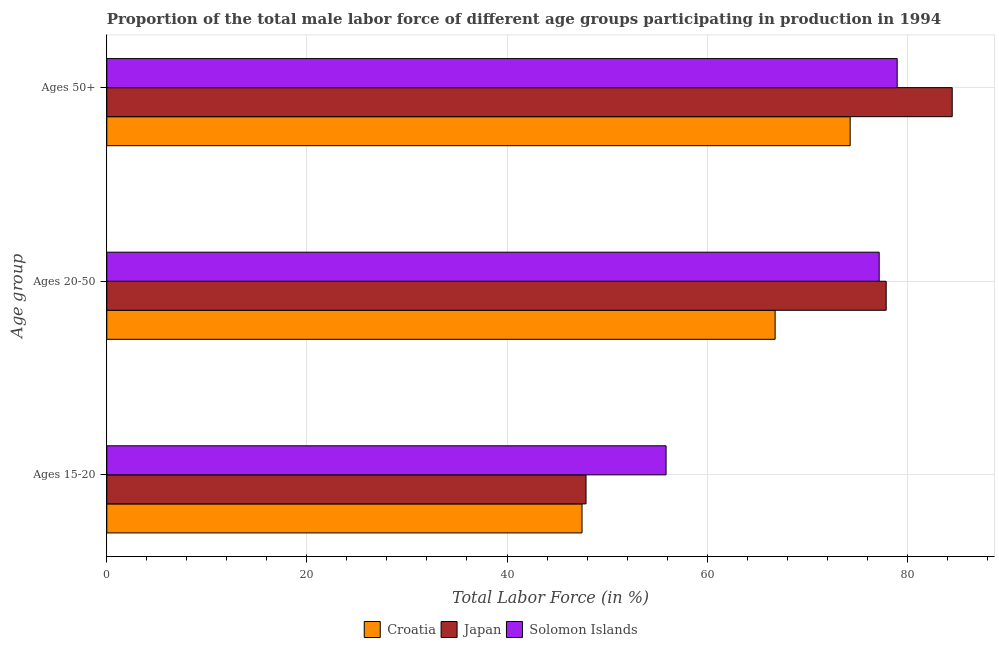How many different coloured bars are there?
Your answer should be compact. 3. What is the label of the 1st group of bars from the top?
Your answer should be compact. Ages 50+. What is the percentage of male labor force within the age group 15-20 in Solomon Islands?
Your answer should be compact. 55.9. Across all countries, what is the maximum percentage of male labor force within the age group 15-20?
Ensure brevity in your answer.  55.9. Across all countries, what is the minimum percentage of male labor force within the age group 15-20?
Give a very brief answer. 47.5. In which country was the percentage of male labor force within the age group 20-50 maximum?
Give a very brief answer. Japan. In which country was the percentage of male labor force within the age group 15-20 minimum?
Offer a very short reply. Croatia. What is the total percentage of male labor force within the age group 15-20 in the graph?
Your answer should be very brief. 151.3. What is the difference between the percentage of male labor force within the age group 20-50 in Solomon Islands and that in Japan?
Ensure brevity in your answer.  -0.7. What is the difference between the percentage of male labor force within the age group 15-20 in Japan and the percentage of male labor force within the age group 20-50 in Solomon Islands?
Keep it short and to the point. -29.3. What is the average percentage of male labor force within the age group 15-20 per country?
Your answer should be compact. 50.43. What is the difference between the percentage of male labor force above age 50 and percentage of male labor force within the age group 15-20 in Solomon Islands?
Ensure brevity in your answer.  23.1. What is the ratio of the percentage of male labor force above age 50 in Croatia to that in Solomon Islands?
Give a very brief answer. 0.94. Is the percentage of male labor force within the age group 15-20 in Japan less than that in Solomon Islands?
Make the answer very short. Yes. What is the difference between the highest and the second highest percentage of male labor force within the age group 20-50?
Keep it short and to the point. 0.7. What is the difference between the highest and the lowest percentage of male labor force above age 50?
Your response must be concise. 10.2. In how many countries, is the percentage of male labor force within the age group 20-50 greater than the average percentage of male labor force within the age group 20-50 taken over all countries?
Offer a terse response. 2. Is the sum of the percentage of male labor force within the age group 15-20 in Solomon Islands and Japan greater than the maximum percentage of male labor force above age 50 across all countries?
Provide a succinct answer. Yes. What does the 3rd bar from the top in Ages 20-50 represents?
Your answer should be very brief. Croatia. What does the 1st bar from the bottom in Ages 15-20 represents?
Offer a very short reply. Croatia. Is it the case that in every country, the sum of the percentage of male labor force within the age group 15-20 and percentage of male labor force within the age group 20-50 is greater than the percentage of male labor force above age 50?
Offer a very short reply. Yes. How many bars are there?
Keep it short and to the point. 9. Does the graph contain any zero values?
Your answer should be very brief. No. Does the graph contain grids?
Your answer should be compact. Yes. Where does the legend appear in the graph?
Ensure brevity in your answer.  Bottom center. How many legend labels are there?
Offer a terse response. 3. How are the legend labels stacked?
Your answer should be compact. Horizontal. What is the title of the graph?
Your answer should be very brief. Proportion of the total male labor force of different age groups participating in production in 1994. Does "India" appear as one of the legend labels in the graph?
Make the answer very short. No. What is the label or title of the Y-axis?
Provide a short and direct response. Age group. What is the Total Labor Force (in %) of Croatia in Ages 15-20?
Ensure brevity in your answer.  47.5. What is the Total Labor Force (in %) in Japan in Ages 15-20?
Provide a succinct answer. 47.9. What is the Total Labor Force (in %) in Solomon Islands in Ages 15-20?
Your response must be concise. 55.9. What is the Total Labor Force (in %) of Croatia in Ages 20-50?
Keep it short and to the point. 66.8. What is the Total Labor Force (in %) in Japan in Ages 20-50?
Keep it short and to the point. 77.9. What is the Total Labor Force (in %) in Solomon Islands in Ages 20-50?
Provide a short and direct response. 77.2. What is the Total Labor Force (in %) in Croatia in Ages 50+?
Provide a short and direct response. 74.3. What is the Total Labor Force (in %) of Japan in Ages 50+?
Your answer should be very brief. 84.5. What is the Total Labor Force (in %) of Solomon Islands in Ages 50+?
Provide a succinct answer. 79. Across all Age group, what is the maximum Total Labor Force (in %) in Croatia?
Your answer should be compact. 74.3. Across all Age group, what is the maximum Total Labor Force (in %) of Japan?
Give a very brief answer. 84.5. Across all Age group, what is the maximum Total Labor Force (in %) of Solomon Islands?
Your answer should be compact. 79. Across all Age group, what is the minimum Total Labor Force (in %) of Croatia?
Provide a succinct answer. 47.5. Across all Age group, what is the minimum Total Labor Force (in %) in Japan?
Your response must be concise. 47.9. Across all Age group, what is the minimum Total Labor Force (in %) of Solomon Islands?
Ensure brevity in your answer.  55.9. What is the total Total Labor Force (in %) of Croatia in the graph?
Give a very brief answer. 188.6. What is the total Total Labor Force (in %) of Japan in the graph?
Ensure brevity in your answer.  210.3. What is the total Total Labor Force (in %) of Solomon Islands in the graph?
Keep it short and to the point. 212.1. What is the difference between the Total Labor Force (in %) in Croatia in Ages 15-20 and that in Ages 20-50?
Your answer should be very brief. -19.3. What is the difference between the Total Labor Force (in %) of Solomon Islands in Ages 15-20 and that in Ages 20-50?
Make the answer very short. -21.3. What is the difference between the Total Labor Force (in %) in Croatia in Ages 15-20 and that in Ages 50+?
Provide a short and direct response. -26.8. What is the difference between the Total Labor Force (in %) of Japan in Ages 15-20 and that in Ages 50+?
Offer a very short reply. -36.6. What is the difference between the Total Labor Force (in %) of Solomon Islands in Ages 15-20 and that in Ages 50+?
Give a very brief answer. -23.1. What is the difference between the Total Labor Force (in %) in Japan in Ages 20-50 and that in Ages 50+?
Your answer should be compact. -6.6. What is the difference between the Total Labor Force (in %) in Solomon Islands in Ages 20-50 and that in Ages 50+?
Your answer should be very brief. -1.8. What is the difference between the Total Labor Force (in %) in Croatia in Ages 15-20 and the Total Labor Force (in %) in Japan in Ages 20-50?
Ensure brevity in your answer.  -30.4. What is the difference between the Total Labor Force (in %) in Croatia in Ages 15-20 and the Total Labor Force (in %) in Solomon Islands in Ages 20-50?
Give a very brief answer. -29.7. What is the difference between the Total Labor Force (in %) of Japan in Ages 15-20 and the Total Labor Force (in %) of Solomon Islands in Ages 20-50?
Keep it short and to the point. -29.3. What is the difference between the Total Labor Force (in %) in Croatia in Ages 15-20 and the Total Labor Force (in %) in Japan in Ages 50+?
Provide a succinct answer. -37. What is the difference between the Total Labor Force (in %) in Croatia in Ages 15-20 and the Total Labor Force (in %) in Solomon Islands in Ages 50+?
Provide a succinct answer. -31.5. What is the difference between the Total Labor Force (in %) in Japan in Ages 15-20 and the Total Labor Force (in %) in Solomon Islands in Ages 50+?
Provide a short and direct response. -31.1. What is the difference between the Total Labor Force (in %) in Croatia in Ages 20-50 and the Total Labor Force (in %) in Japan in Ages 50+?
Your answer should be very brief. -17.7. What is the difference between the Total Labor Force (in %) of Japan in Ages 20-50 and the Total Labor Force (in %) of Solomon Islands in Ages 50+?
Provide a succinct answer. -1.1. What is the average Total Labor Force (in %) of Croatia per Age group?
Make the answer very short. 62.87. What is the average Total Labor Force (in %) in Japan per Age group?
Offer a terse response. 70.1. What is the average Total Labor Force (in %) in Solomon Islands per Age group?
Keep it short and to the point. 70.7. What is the difference between the Total Labor Force (in %) in Japan and Total Labor Force (in %) in Solomon Islands in Ages 15-20?
Your answer should be compact. -8. What is the difference between the Total Labor Force (in %) of Croatia and Total Labor Force (in %) of Japan in Ages 20-50?
Your answer should be compact. -11.1. What is the difference between the Total Labor Force (in %) of Japan and Total Labor Force (in %) of Solomon Islands in Ages 20-50?
Provide a succinct answer. 0.7. What is the difference between the Total Labor Force (in %) of Croatia and Total Labor Force (in %) of Solomon Islands in Ages 50+?
Keep it short and to the point. -4.7. What is the ratio of the Total Labor Force (in %) in Croatia in Ages 15-20 to that in Ages 20-50?
Ensure brevity in your answer.  0.71. What is the ratio of the Total Labor Force (in %) in Japan in Ages 15-20 to that in Ages 20-50?
Give a very brief answer. 0.61. What is the ratio of the Total Labor Force (in %) in Solomon Islands in Ages 15-20 to that in Ages 20-50?
Keep it short and to the point. 0.72. What is the ratio of the Total Labor Force (in %) in Croatia in Ages 15-20 to that in Ages 50+?
Offer a very short reply. 0.64. What is the ratio of the Total Labor Force (in %) of Japan in Ages 15-20 to that in Ages 50+?
Keep it short and to the point. 0.57. What is the ratio of the Total Labor Force (in %) in Solomon Islands in Ages 15-20 to that in Ages 50+?
Offer a very short reply. 0.71. What is the ratio of the Total Labor Force (in %) in Croatia in Ages 20-50 to that in Ages 50+?
Give a very brief answer. 0.9. What is the ratio of the Total Labor Force (in %) of Japan in Ages 20-50 to that in Ages 50+?
Make the answer very short. 0.92. What is the ratio of the Total Labor Force (in %) of Solomon Islands in Ages 20-50 to that in Ages 50+?
Offer a very short reply. 0.98. What is the difference between the highest and the second highest Total Labor Force (in %) of Croatia?
Offer a very short reply. 7.5. What is the difference between the highest and the second highest Total Labor Force (in %) in Solomon Islands?
Your answer should be very brief. 1.8. What is the difference between the highest and the lowest Total Labor Force (in %) of Croatia?
Your answer should be compact. 26.8. What is the difference between the highest and the lowest Total Labor Force (in %) of Japan?
Make the answer very short. 36.6. What is the difference between the highest and the lowest Total Labor Force (in %) of Solomon Islands?
Ensure brevity in your answer.  23.1. 